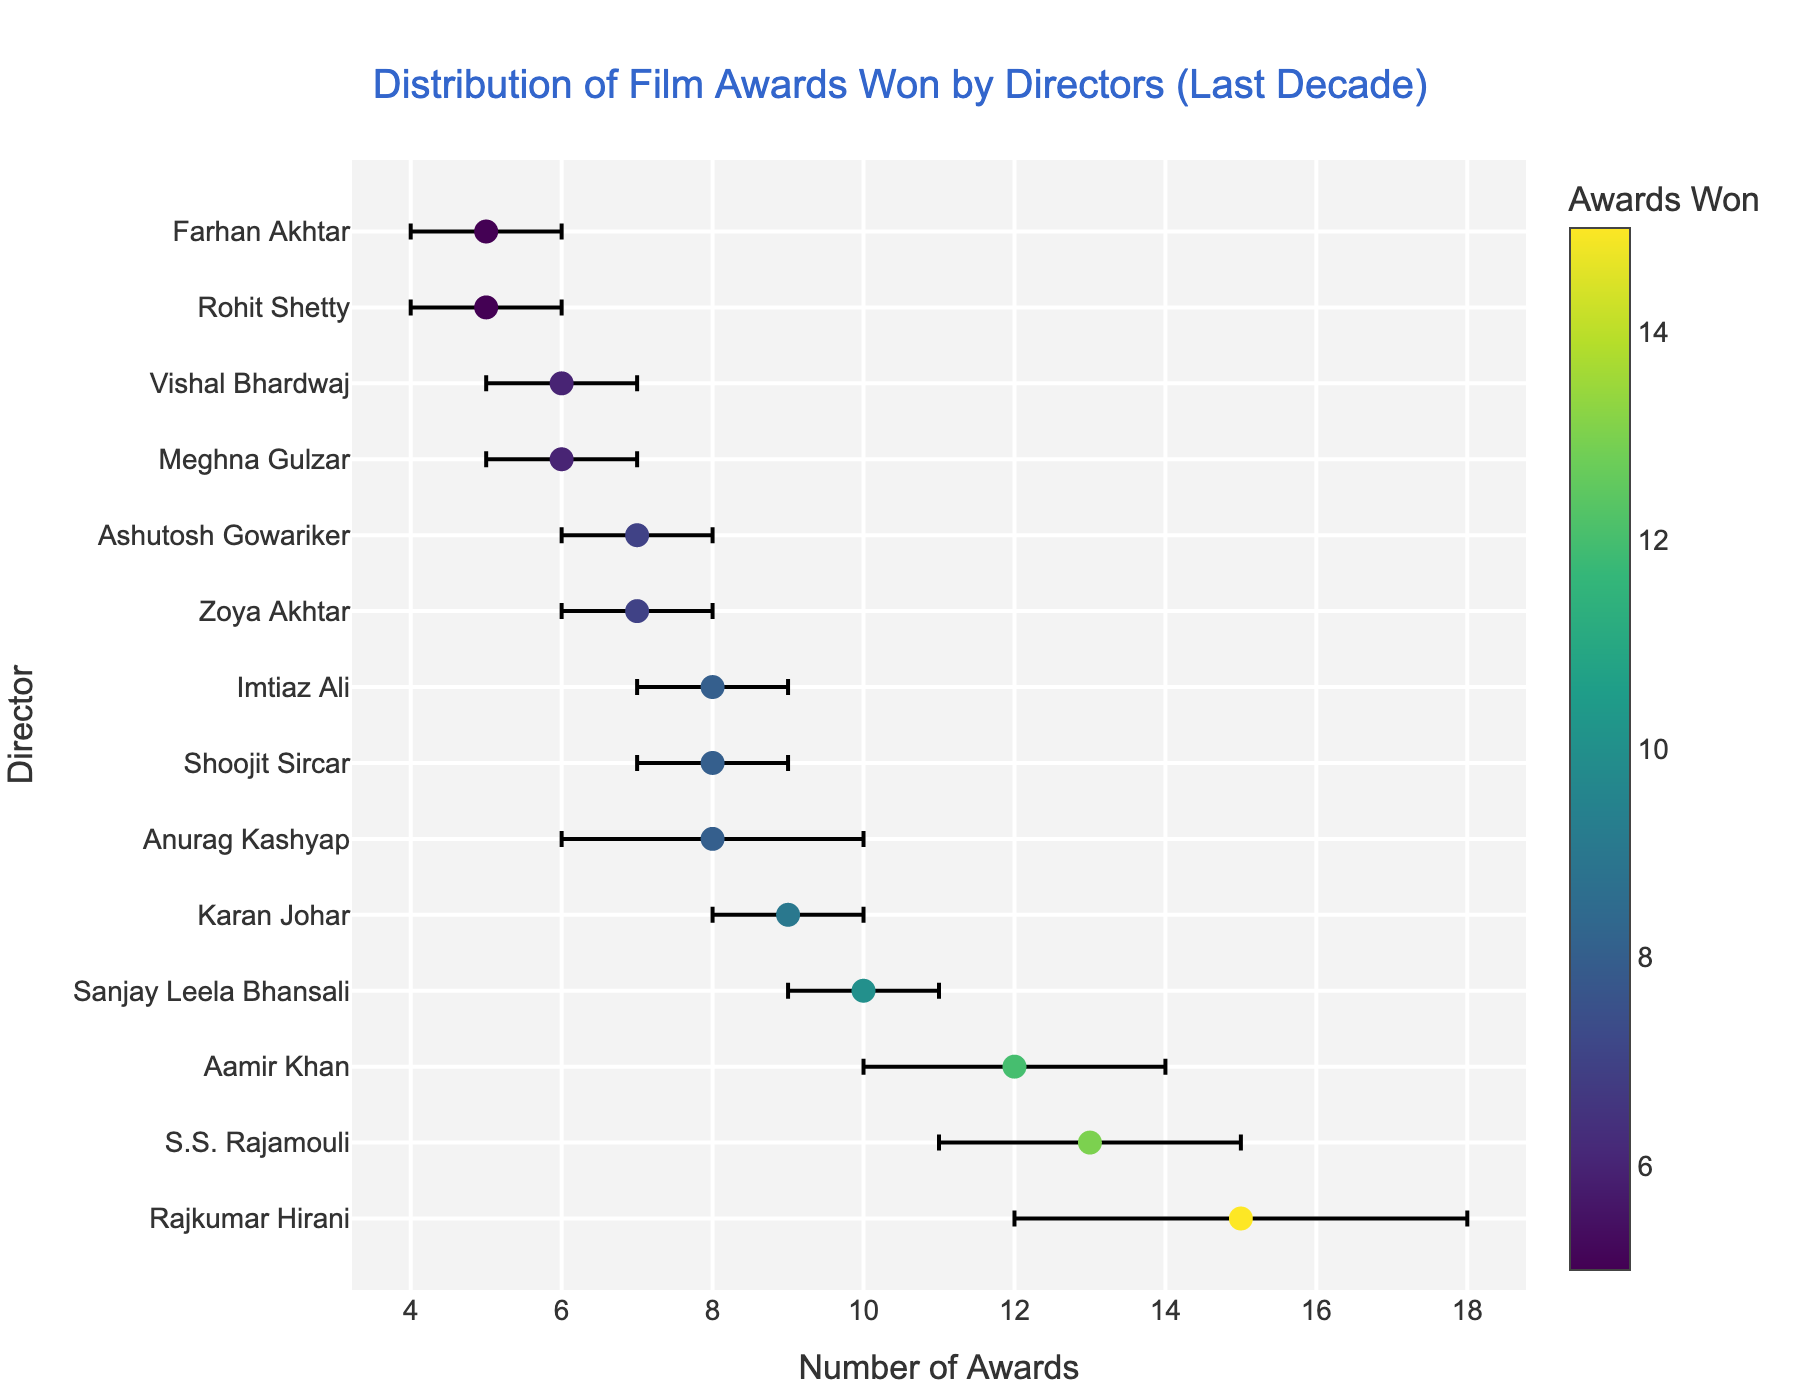what is the title of the plot? The title is usually found at the top of the plot, and it summarizes the content. Here, it reads "Distribution of Film Awards Won by Directors (Last Decade)."
Answer: Distribution of Film Awards Won by Directors (Last Decade) what is the horizontal axis representing? The horizontal axis denotes the number of awards won, as indicated by the axis title "Number of Awards."
Answer: Number of Awards which director has won the most awards? By looking at the plot, the dot farthest to the right in the list represents Rajkumar Hirani with 15 awards.
Answer: Rajkumar Hirani what is the range of error margins present in the plot? The error margins vary from the smallest value of ±1 to the largest value of ±3. This can be observed from the error bars attached to each dot.
Answer: ±1 to ±3 who has the largest error margin, and what is it? Rajkumar Hirani has the largest error margin, which is ±3. This can be found by identifying the largest error bar, which is associated with him.
Answer: Rajkumar Hirani, ±3 how many directors have an error margin of ±2? By observing the error bars, the directors with an error margin of ±2 are Aamir Khan, S.S. Rajamouli, and Anurag Kashyap. There are 3 such directors.
Answer: 3 which director has the smallest number of awards, and what is it? The smallest number of awards can be found by looking at the dot farthest to the left, which corresponds to Rohit Shetty with 5 awards.
Answer: Rohit Shetty, 5 who has earned more awards, Anurag Kashyap or Zoya Akhtar, and by how many? By comparing their positions, Anurag Kashyap has 8 awards, while Zoya Akhtar has 7. The difference is 8 - 7 = 1.
Answer: Anurag Kashyap, 1 how many directors have won exactly 8 awards? By locating all the dots that are positioned at 8 on the horizontal axis, the directors are Anurag Kashyap, Shoojit Sircar, and Imtiaz Ali. There are 3 such directors.
Answer: 3 what is the total number of awards won by Aamir Khan and S.S. Rajamouli combined? Aamir Khan has 12 awards, and S.S. Rajamouli has 13 awards. Their combined total is 12 + 13 = 25.
Answer: 25 